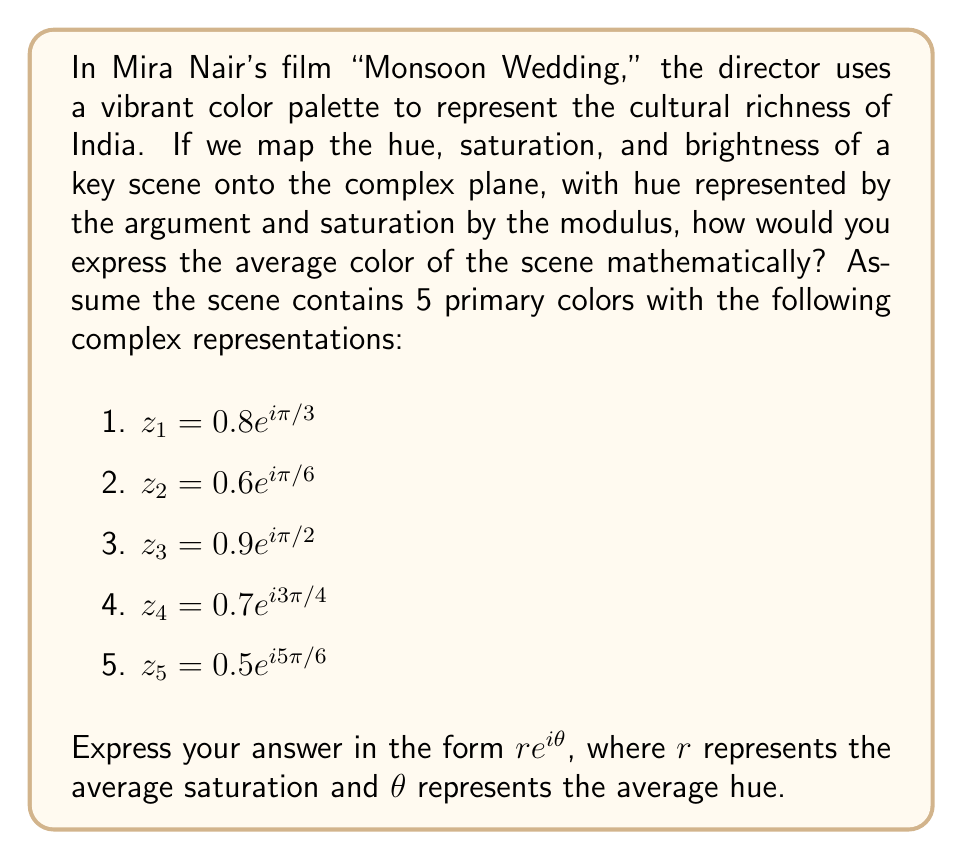Could you help me with this problem? To solve this problem, we need to find the average of the given complex numbers. This can be done by adding all the complex numbers and dividing by the total number of colors.

Step 1: Add all the complex numbers
$$z_{total} = z_1 + z_2 + z_3 + z_4 + z_5$$

Step 2: Express each complex number in rectangular form
$z_1 = 0.8(\cos(\pi/3) + i\sin(\pi/3))$
$z_2 = 0.6(\cos(\pi/6) + i\sin(\pi/6))$
$z_3 = 0.9(\cos(\pi/2) + i\sin(\pi/2))$
$z_4 = 0.7(\cos(3\pi/4) + i\sin(3\pi/4))$
$z_5 = 0.5(\cos(5\pi/6) + i\sin(5\pi/6))$

Step 3: Add the real and imaginary parts separately
Real part: $0.8\cos(\pi/3) + 0.6\cos(\pi/6) + 0.9\cos(\pi/2) + 0.7\cos(3\pi/4) + 0.5\cos(5\pi/6)$
Imaginary part: $0.8\sin(\pi/3) + 0.6\sin(\pi/6) + 0.9\sin(\pi/2) + 0.7\sin(3\pi/4) + 0.5\sin(5\pi/6)$

Step 4: Calculate the sum
$z_{total} \approx 1.0392 + 2.1447i$

Step 5: Divide by the number of colors (5) to get the average
$z_{avg} = \frac{z_{total}}{5} \approx 0.2078 + 0.4289i$

Step 6: Convert the average back to polar form
$r = \sqrt{(0.2078)^2 + (0.4289)^2} \approx 0.4765$
$\theta = \tan^{-1}(\frac{0.4289}{0.2078}) \approx 1.1215$ radians

Therefore, the average color can be expressed as $0.4765e^{i1.1215}$.
Answer: $0.4765e^{i1.1215}$ 